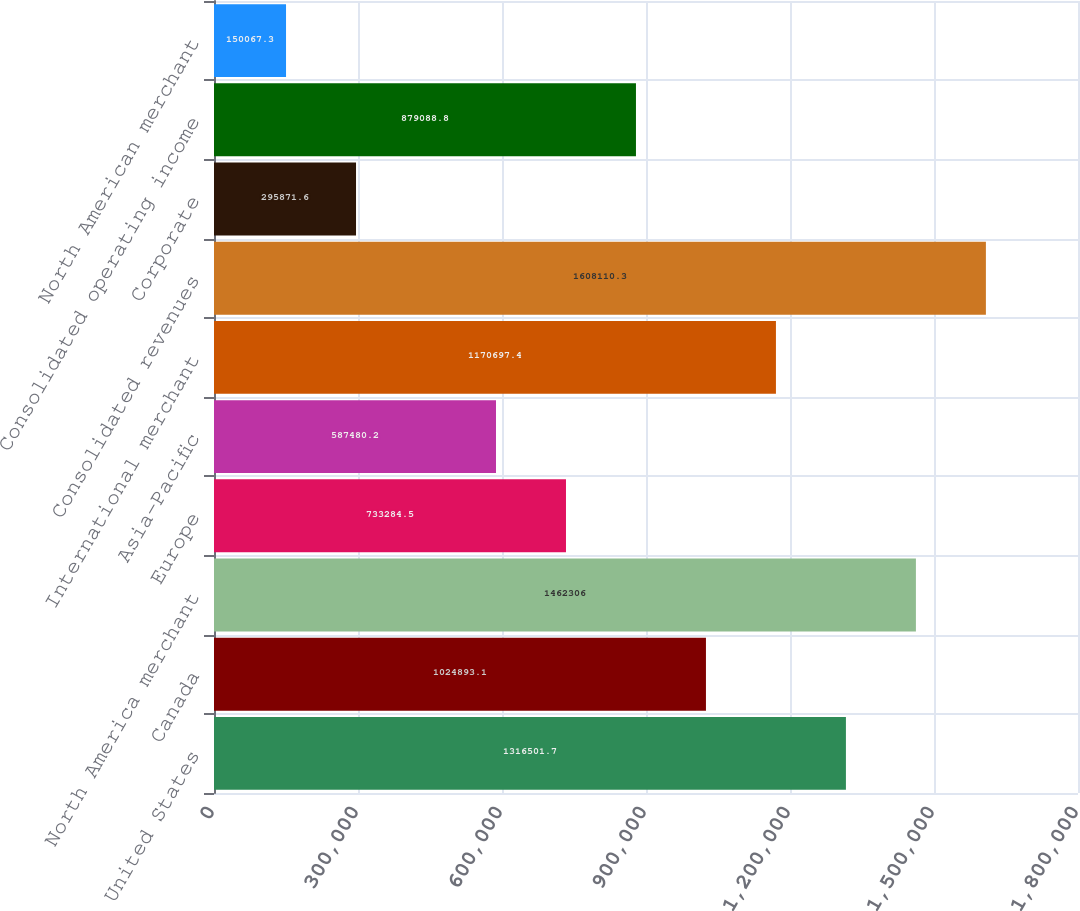Convert chart. <chart><loc_0><loc_0><loc_500><loc_500><bar_chart><fcel>United States<fcel>Canada<fcel>North America merchant<fcel>Europe<fcel>Asia-Pacific<fcel>International merchant<fcel>Consolidated revenues<fcel>Corporate<fcel>Consolidated operating income<fcel>North American merchant<nl><fcel>1.3165e+06<fcel>1.02489e+06<fcel>1.46231e+06<fcel>733284<fcel>587480<fcel>1.1707e+06<fcel>1.60811e+06<fcel>295872<fcel>879089<fcel>150067<nl></chart> 